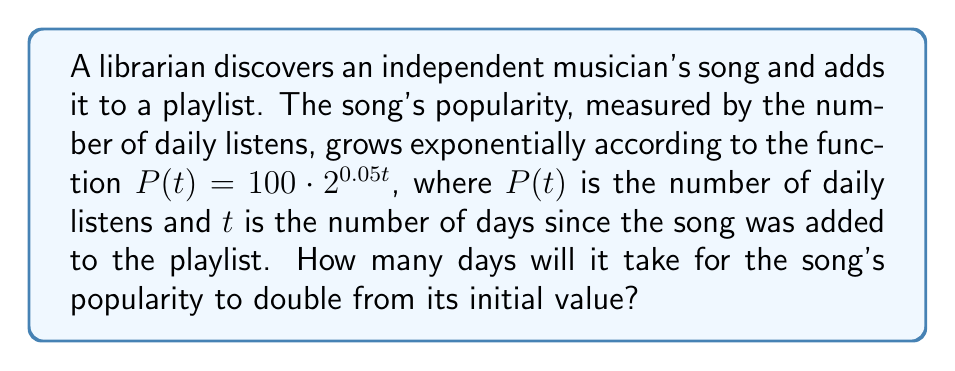Provide a solution to this math problem. Let's approach this step-by-step:

1) The initial popularity (at $t=0$) is:
   $P(0) = 100 \cdot 2^{0.05 \cdot 0} = 100$ daily listens

2) We want to find when the popularity reaches twice this value:
   $2P(0) = 2 \cdot 100 = 200$ daily listens

3) We can set up the equation:
   $200 = 100 \cdot 2^{0.05t}$

4) Dividing both sides by 100:
   $2 = 2^{0.05t}$

5) Taking the logarithm (base 2) of both sides:
   $\log_2(2) = \log_2(2^{0.05t})$

6) Simplify the left side and use the logarithm power rule on the right:
   $1 = 0.05t \cdot \log_2(2)$

7) Since $\log_2(2) = 1$, we have:
   $1 = 0.05t$

8) Solving for $t$:
   $t = \frac{1}{0.05} = 20$

Therefore, it will take 20 days for the song's popularity to double.
Answer: 20 days 